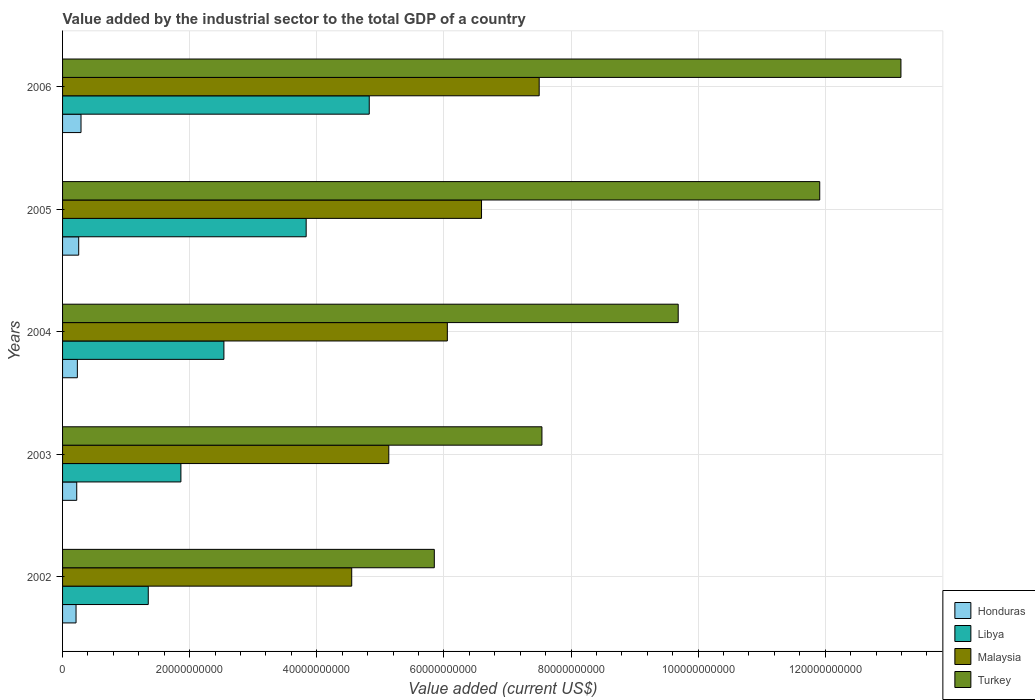Are the number of bars per tick equal to the number of legend labels?
Keep it short and to the point. Yes. Are the number of bars on each tick of the Y-axis equal?
Provide a short and direct response. Yes. What is the label of the 5th group of bars from the top?
Make the answer very short. 2002. In how many cases, is the number of bars for a given year not equal to the number of legend labels?
Your response must be concise. 0. What is the value added by the industrial sector to the total GDP in Malaysia in 2005?
Give a very brief answer. 6.59e+1. Across all years, what is the maximum value added by the industrial sector to the total GDP in Libya?
Your answer should be compact. 4.83e+1. Across all years, what is the minimum value added by the industrial sector to the total GDP in Turkey?
Give a very brief answer. 5.85e+1. In which year was the value added by the industrial sector to the total GDP in Malaysia maximum?
Provide a succinct answer. 2006. What is the total value added by the industrial sector to the total GDP in Malaysia in the graph?
Keep it short and to the point. 2.98e+11. What is the difference between the value added by the industrial sector to the total GDP in Malaysia in 2004 and that in 2005?
Ensure brevity in your answer.  -5.38e+09. What is the difference between the value added by the industrial sector to the total GDP in Malaysia in 2006 and the value added by the industrial sector to the total GDP in Honduras in 2003?
Provide a succinct answer. 7.28e+1. What is the average value added by the industrial sector to the total GDP in Malaysia per year?
Provide a succinct answer. 5.97e+1. In the year 2005, what is the difference between the value added by the industrial sector to the total GDP in Malaysia and value added by the industrial sector to the total GDP in Libya?
Your response must be concise. 2.76e+1. In how many years, is the value added by the industrial sector to the total GDP in Honduras greater than 44000000000 US$?
Ensure brevity in your answer.  0. What is the ratio of the value added by the industrial sector to the total GDP in Turkey in 2004 to that in 2005?
Provide a short and direct response. 0.81. Is the difference between the value added by the industrial sector to the total GDP in Malaysia in 2002 and 2005 greater than the difference between the value added by the industrial sector to the total GDP in Libya in 2002 and 2005?
Provide a short and direct response. Yes. What is the difference between the highest and the second highest value added by the industrial sector to the total GDP in Libya?
Provide a succinct answer. 9.93e+09. What is the difference between the highest and the lowest value added by the industrial sector to the total GDP in Turkey?
Ensure brevity in your answer.  7.34e+1. In how many years, is the value added by the industrial sector to the total GDP in Malaysia greater than the average value added by the industrial sector to the total GDP in Malaysia taken over all years?
Offer a very short reply. 3. Is the sum of the value added by the industrial sector to the total GDP in Malaysia in 2002 and 2003 greater than the maximum value added by the industrial sector to the total GDP in Libya across all years?
Offer a terse response. Yes. Is it the case that in every year, the sum of the value added by the industrial sector to the total GDP in Malaysia and value added by the industrial sector to the total GDP in Libya is greater than the sum of value added by the industrial sector to the total GDP in Honduras and value added by the industrial sector to the total GDP in Turkey?
Keep it short and to the point. Yes. What does the 3rd bar from the top in 2005 represents?
Offer a terse response. Libya. What does the 1st bar from the bottom in 2002 represents?
Ensure brevity in your answer.  Honduras. Is it the case that in every year, the sum of the value added by the industrial sector to the total GDP in Malaysia and value added by the industrial sector to the total GDP in Libya is greater than the value added by the industrial sector to the total GDP in Turkey?
Your response must be concise. No. How many years are there in the graph?
Your answer should be compact. 5. Does the graph contain grids?
Your answer should be very brief. Yes. What is the title of the graph?
Give a very brief answer. Value added by the industrial sector to the total GDP of a country. What is the label or title of the X-axis?
Keep it short and to the point. Value added (current US$). What is the Value added (current US$) of Honduras in 2002?
Your response must be concise. 2.12e+09. What is the Value added (current US$) of Libya in 2002?
Provide a succinct answer. 1.35e+1. What is the Value added (current US$) in Malaysia in 2002?
Keep it short and to the point. 4.55e+1. What is the Value added (current US$) of Turkey in 2002?
Provide a succinct answer. 5.85e+1. What is the Value added (current US$) in Honduras in 2003?
Offer a very short reply. 2.23e+09. What is the Value added (current US$) in Libya in 2003?
Provide a succinct answer. 1.86e+1. What is the Value added (current US$) of Malaysia in 2003?
Ensure brevity in your answer.  5.13e+1. What is the Value added (current US$) in Turkey in 2003?
Give a very brief answer. 7.54e+1. What is the Value added (current US$) in Honduras in 2004?
Your answer should be very brief. 2.33e+09. What is the Value added (current US$) in Libya in 2004?
Make the answer very short. 2.54e+1. What is the Value added (current US$) in Malaysia in 2004?
Your response must be concise. 6.05e+1. What is the Value added (current US$) of Turkey in 2004?
Ensure brevity in your answer.  9.69e+1. What is the Value added (current US$) of Honduras in 2005?
Your answer should be very brief. 2.54e+09. What is the Value added (current US$) of Libya in 2005?
Provide a short and direct response. 3.83e+1. What is the Value added (current US$) of Malaysia in 2005?
Your answer should be very brief. 6.59e+1. What is the Value added (current US$) of Turkey in 2005?
Offer a very short reply. 1.19e+11. What is the Value added (current US$) of Honduras in 2006?
Your response must be concise. 2.90e+09. What is the Value added (current US$) in Libya in 2006?
Provide a succinct answer. 4.83e+1. What is the Value added (current US$) in Malaysia in 2006?
Your answer should be very brief. 7.50e+1. What is the Value added (current US$) in Turkey in 2006?
Offer a very short reply. 1.32e+11. Across all years, what is the maximum Value added (current US$) in Honduras?
Give a very brief answer. 2.90e+09. Across all years, what is the maximum Value added (current US$) in Libya?
Make the answer very short. 4.83e+1. Across all years, what is the maximum Value added (current US$) in Malaysia?
Offer a terse response. 7.50e+1. Across all years, what is the maximum Value added (current US$) in Turkey?
Ensure brevity in your answer.  1.32e+11. Across all years, what is the minimum Value added (current US$) of Honduras?
Your answer should be compact. 2.12e+09. Across all years, what is the minimum Value added (current US$) of Libya?
Your answer should be very brief. 1.35e+1. Across all years, what is the minimum Value added (current US$) in Malaysia?
Your response must be concise. 4.55e+1. Across all years, what is the minimum Value added (current US$) in Turkey?
Offer a very short reply. 5.85e+1. What is the total Value added (current US$) of Honduras in the graph?
Offer a terse response. 1.21e+1. What is the total Value added (current US$) of Libya in the graph?
Make the answer very short. 1.44e+11. What is the total Value added (current US$) of Malaysia in the graph?
Keep it short and to the point. 2.98e+11. What is the total Value added (current US$) of Turkey in the graph?
Provide a short and direct response. 4.82e+11. What is the difference between the Value added (current US$) of Honduras in 2002 and that in 2003?
Make the answer very short. -1.08e+08. What is the difference between the Value added (current US$) in Libya in 2002 and that in 2003?
Offer a terse response. -5.14e+09. What is the difference between the Value added (current US$) of Malaysia in 2002 and that in 2003?
Keep it short and to the point. -5.83e+09. What is the difference between the Value added (current US$) in Turkey in 2002 and that in 2003?
Give a very brief answer. -1.69e+1. What is the difference between the Value added (current US$) in Honduras in 2002 and that in 2004?
Provide a short and direct response. -2.08e+08. What is the difference between the Value added (current US$) of Libya in 2002 and that in 2004?
Keep it short and to the point. -1.19e+1. What is the difference between the Value added (current US$) in Malaysia in 2002 and that in 2004?
Give a very brief answer. -1.50e+1. What is the difference between the Value added (current US$) of Turkey in 2002 and that in 2004?
Keep it short and to the point. -3.84e+1. What is the difference between the Value added (current US$) of Honduras in 2002 and that in 2005?
Offer a very short reply. -4.18e+08. What is the difference between the Value added (current US$) of Libya in 2002 and that in 2005?
Give a very brief answer. -2.48e+1. What is the difference between the Value added (current US$) of Malaysia in 2002 and that in 2005?
Provide a short and direct response. -2.04e+1. What is the difference between the Value added (current US$) in Turkey in 2002 and that in 2005?
Offer a very short reply. -6.06e+1. What is the difference between the Value added (current US$) of Honduras in 2002 and that in 2006?
Provide a short and direct response. -7.84e+08. What is the difference between the Value added (current US$) in Libya in 2002 and that in 2006?
Your response must be concise. -3.48e+1. What is the difference between the Value added (current US$) of Malaysia in 2002 and that in 2006?
Give a very brief answer. -2.95e+1. What is the difference between the Value added (current US$) of Turkey in 2002 and that in 2006?
Offer a very short reply. -7.34e+1. What is the difference between the Value added (current US$) in Honduras in 2003 and that in 2004?
Offer a terse response. -9.98e+07. What is the difference between the Value added (current US$) of Libya in 2003 and that in 2004?
Ensure brevity in your answer.  -6.77e+09. What is the difference between the Value added (current US$) of Malaysia in 2003 and that in 2004?
Provide a short and direct response. -9.21e+09. What is the difference between the Value added (current US$) of Turkey in 2003 and that in 2004?
Make the answer very short. -2.14e+1. What is the difference between the Value added (current US$) in Honduras in 2003 and that in 2005?
Your answer should be very brief. -3.10e+08. What is the difference between the Value added (current US$) of Libya in 2003 and that in 2005?
Your answer should be very brief. -1.97e+1. What is the difference between the Value added (current US$) of Malaysia in 2003 and that in 2005?
Your response must be concise. -1.46e+1. What is the difference between the Value added (current US$) in Turkey in 2003 and that in 2005?
Offer a very short reply. -4.37e+1. What is the difference between the Value added (current US$) of Honduras in 2003 and that in 2006?
Provide a short and direct response. -6.76e+08. What is the difference between the Value added (current US$) of Libya in 2003 and that in 2006?
Provide a short and direct response. -2.96e+1. What is the difference between the Value added (current US$) in Malaysia in 2003 and that in 2006?
Your response must be concise. -2.37e+1. What is the difference between the Value added (current US$) of Turkey in 2003 and that in 2006?
Your response must be concise. -5.65e+1. What is the difference between the Value added (current US$) in Honduras in 2004 and that in 2005?
Your answer should be very brief. -2.10e+08. What is the difference between the Value added (current US$) of Libya in 2004 and that in 2005?
Your answer should be very brief. -1.29e+1. What is the difference between the Value added (current US$) in Malaysia in 2004 and that in 2005?
Give a very brief answer. -5.38e+09. What is the difference between the Value added (current US$) in Turkey in 2004 and that in 2005?
Offer a very short reply. -2.23e+1. What is the difference between the Value added (current US$) in Honduras in 2004 and that in 2006?
Your answer should be compact. -5.76e+08. What is the difference between the Value added (current US$) of Libya in 2004 and that in 2006?
Offer a terse response. -2.29e+1. What is the difference between the Value added (current US$) of Malaysia in 2004 and that in 2006?
Offer a terse response. -1.45e+1. What is the difference between the Value added (current US$) of Turkey in 2004 and that in 2006?
Your answer should be compact. -3.50e+1. What is the difference between the Value added (current US$) of Honduras in 2005 and that in 2006?
Your answer should be very brief. -3.66e+08. What is the difference between the Value added (current US$) of Libya in 2005 and that in 2006?
Give a very brief answer. -9.93e+09. What is the difference between the Value added (current US$) in Malaysia in 2005 and that in 2006?
Give a very brief answer. -9.07e+09. What is the difference between the Value added (current US$) in Turkey in 2005 and that in 2006?
Give a very brief answer. -1.28e+1. What is the difference between the Value added (current US$) in Honduras in 2002 and the Value added (current US$) in Libya in 2003?
Ensure brevity in your answer.  -1.65e+1. What is the difference between the Value added (current US$) of Honduras in 2002 and the Value added (current US$) of Malaysia in 2003?
Your answer should be compact. -4.92e+1. What is the difference between the Value added (current US$) of Honduras in 2002 and the Value added (current US$) of Turkey in 2003?
Your answer should be very brief. -7.33e+1. What is the difference between the Value added (current US$) of Libya in 2002 and the Value added (current US$) of Malaysia in 2003?
Ensure brevity in your answer.  -3.78e+1. What is the difference between the Value added (current US$) of Libya in 2002 and the Value added (current US$) of Turkey in 2003?
Provide a short and direct response. -6.19e+1. What is the difference between the Value added (current US$) of Malaysia in 2002 and the Value added (current US$) of Turkey in 2003?
Your response must be concise. -2.99e+1. What is the difference between the Value added (current US$) in Honduras in 2002 and the Value added (current US$) in Libya in 2004?
Offer a terse response. -2.33e+1. What is the difference between the Value added (current US$) in Honduras in 2002 and the Value added (current US$) in Malaysia in 2004?
Provide a succinct answer. -5.84e+1. What is the difference between the Value added (current US$) of Honduras in 2002 and the Value added (current US$) of Turkey in 2004?
Ensure brevity in your answer.  -9.47e+1. What is the difference between the Value added (current US$) in Libya in 2002 and the Value added (current US$) in Malaysia in 2004?
Offer a very short reply. -4.71e+1. What is the difference between the Value added (current US$) of Libya in 2002 and the Value added (current US$) of Turkey in 2004?
Provide a succinct answer. -8.34e+1. What is the difference between the Value added (current US$) in Malaysia in 2002 and the Value added (current US$) in Turkey in 2004?
Offer a terse response. -5.14e+1. What is the difference between the Value added (current US$) of Honduras in 2002 and the Value added (current US$) of Libya in 2005?
Ensure brevity in your answer.  -3.62e+1. What is the difference between the Value added (current US$) in Honduras in 2002 and the Value added (current US$) in Malaysia in 2005?
Your response must be concise. -6.38e+1. What is the difference between the Value added (current US$) in Honduras in 2002 and the Value added (current US$) in Turkey in 2005?
Make the answer very short. -1.17e+11. What is the difference between the Value added (current US$) of Libya in 2002 and the Value added (current US$) of Malaysia in 2005?
Offer a terse response. -5.24e+1. What is the difference between the Value added (current US$) of Libya in 2002 and the Value added (current US$) of Turkey in 2005?
Offer a terse response. -1.06e+11. What is the difference between the Value added (current US$) of Malaysia in 2002 and the Value added (current US$) of Turkey in 2005?
Your answer should be very brief. -7.36e+1. What is the difference between the Value added (current US$) of Honduras in 2002 and the Value added (current US$) of Libya in 2006?
Offer a terse response. -4.61e+1. What is the difference between the Value added (current US$) in Honduras in 2002 and the Value added (current US$) in Malaysia in 2006?
Your answer should be very brief. -7.29e+1. What is the difference between the Value added (current US$) of Honduras in 2002 and the Value added (current US$) of Turkey in 2006?
Keep it short and to the point. -1.30e+11. What is the difference between the Value added (current US$) in Libya in 2002 and the Value added (current US$) in Malaysia in 2006?
Make the answer very short. -6.15e+1. What is the difference between the Value added (current US$) in Libya in 2002 and the Value added (current US$) in Turkey in 2006?
Make the answer very short. -1.18e+11. What is the difference between the Value added (current US$) in Malaysia in 2002 and the Value added (current US$) in Turkey in 2006?
Give a very brief answer. -8.64e+1. What is the difference between the Value added (current US$) of Honduras in 2003 and the Value added (current US$) of Libya in 2004?
Your response must be concise. -2.32e+1. What is the difference between the Value added (current US$) in Honduras in 2003 and the Value added (current US$) in Malaysia in 2004?
Keep it short and to the point. -5.83e+1. What is the difference between the Value added (current US$) in Honduras in 2003 and the Value added (current US$) in Turkey in 2004?
Offer a very short reply. -9.46e+1. What is the difference between the Value added (current US$) in Libya in 2003 and the Value added (current US$) in Malaysia in 2004?
Offer a very short reply. -4.19e+1. What is the difference between the Value added (current US$) in Libya in 2003 and the Value added (current US$) in Turkey in 2004?
Provide a succinct answer. -7.82e+1. What is the difference between the Value added (current US$) in Malaysia in 2003 and the Value added (current US$) in Turkey in 2004?
Keep it short and to the point. -4.55e+1. What is the difference between the Value added (current US$) of Honduras in 2003 and the Value added (current US$) of Libya in 2005?
Keep it short and to the point. -3.61e+1. What is the difference between the Value added (current US$) of Honduras in 2003 and the Value added (current US$) of Malaysia in 2005?
Provide a short and direct response. -6.37e+1. What is the difference between the Value added (current US$) in Honduras in 2003 and the Value added (current US$) in Turkey in 2005?
Give a very brief answer. -1.17e+11. What is the difference between the Value added (current US$) in Libya in 2003 and the Value added (current US$) in Malaysia in 2005?
Your answer should be compact. -4.73e+1. What is the difference between the Value added (current US$) in Libya in 2003 and the Value added (current US$) in Turkey in 2005?
Keep it short and to the point. -1.01e+11. What is the difference between the Value added (current US$) in Malaysia in 2003 and the Value added (current US$) in Turkey in 2005?
Your answer should be very brief. -6.78e+1. What is the difference between the Value added (current US$) of Honduras in 2003 and the Value added (current US$) of Libya in 2006?
Keep it short and to the point. -4.60e+1. What is the difference between the Value added (current US$) of Honduras in 2003 and the Value added (current US$) of Malaysia in 2006?
Your answer should be compact. -7.28e+1. What is the difference between the Value added (current US$) in Honduras in 2003 and the Value added (current US$) in Turkey in 2006?
Your answer should be very brief. -1.30e+11. What is the difference between the Value added (current US$) of Libya in 2003 and the Value added (current US$) of Malaysia in 2006?
Your answer should be compact. -5.64e+1. What is the difference between the Value added (current US$) in Libya in 2003 and the Value added (current US$) in Turkey in 2006?
Ensure brevity in your answer.  -1.13e+11. What is the difference between the Value added (current US$) of Malaysia in 2003 and the Value added (current US$) of Turkey in 2006?
Give a very brief answer. -8.06e+1. What is the difference between the Value added (current US$) of Honduras in 2004 and the Value added (current US$) of Libya in 2005?
Give a very brief answer. -3.60e+1. What is the difference between the Value added (current US$) of Honduras in 2004 and the Value added (current US$) of Malaysia in 2005?
Provide a short and direct response. -6.36e+1. What is the difference between the Value added (current US$) of Honduras in 2004 and the Value added (current US$) of Turkey in 2005?
Ensure brevity in your answer.  -1.17e+11. What is the difference between the Value added (current US$) of Libya in 2004 and the Value added (current US$) of Malaysia in 2005?
Keep it short and to the point. -4.05e+1. What is the difference between the Value added (current US$) of Libya in 2004 and the Value added (current US$) of Turkey in 2005?
Provide a succinct answer. -9.37e+1. What is the difference between the Value added (current US$) in Malaysia in 2004 and the Value added (current US$) in Turkey in 2005?
Your response must be concise. -5.86e+1. What is the difference between the Value added (current US$) in Honduras in 2004 and the Value added (current US$) in Libya in 2006?
Keep it short and to the point. -4.59e+1. What is the difference between the Value added (current US$) of Honduras in 2004 and the Value added (current US$) of Malaysia in 2006?
Provide a short and direct response. -7.27e+1. What is the difference between the Value added (current US$) of Honduras in 2004 and the Value added (current US$) of Turkey in 2006?
Your response must be concise. -1.30e+11. What is the difference between the Value added (current US$) in Libya in 2004 and the Value added (current US$) in Malaysia in 2006?
Your answer should be compact. -4.96e+1. What is the difference between the Value added (current US$) of Libya in 2004 and the Value added (current US$) of Turkey in 2006?
Your answer should be compact. -1.07e+11. What is the difference between the Value added (current US$) in Malaysia in 2004 and the Value added (current US$) in Turkey in 2006?
Your answer should be very brief. -7.14e+1. What is the difference between the Value added (current US$) of Honduras in 2005 and the Value added (current US$) of Libya in 2006?
Your answer should be compact. -4.57e+1. What is the difference between the Value added (current US$) in Honduras in 2005 and the Value added (current US$) in Malaysia in 2006?
Give a very brief answer. -7.25e+1. What is the difference between the Value added (current US$) in Honduras in 2005 and the Value added (current US$) in Turkey in 2006?
Offer a very short reply. -1.29e+11. What is the difference between the Value added (current US$) of Libya in 2005 and the Value added (current US$) of Malaysia in 2006?
Your answer should be compact. -3.67e+1. What is the difference between the Value added (current US$) in Libya in 2005 and the Value added (current US$) in Turkey in 2006?
Your response must be concise. -9.36e+1. What is the difference between the Value added (current US$) in Malaysia in 2005 and the Value added (current US$) in Turkey in 2006?
Your answer should be compact. -6.60e+1. What is the average Value added (current US$) in Honduras per year?
Offer a terse response. 2.42e+09. What is the average Value added (current US$) of Libya per year?
Make the answer very short. 2.88e+1. What is the average Value added (current US$) of Malaysia per year?
Offer a terse response. 5.97e+1. What is the average Value added (current US$) of Turkey per year?
Offer a terse response. 9.64e+1. In the year 2002, what is the difference between the Value added (current US$) of Honduras and Value added (current US$) of Libya?
Offer a terse response. -1.14e+1. In the year 2002, what is the difference between the Value added (current US$) in Honduras and Value added (current US$) in Malaysia?
Make the answer very short. -4.34e+1. In the year 2002, what is the difference between the Value added (current US$) in Honduras and Value added (current US$) in Turkey?
Provide a short and direct response. -5.64e+1. In the year 2002, what is the difference between the Value added (current US$) in Libya and Value added (current US$) in Malaysia?
Provide a short and direct response. -3.20e+1. In the year 2002, what is the difference between the Value added (current US$) in Libya and Value added (current US$) in Turkey?
Ensure brevity in your answer.  -4.50e+1. In the year 2002, what is the difference between the Value added (current US$) of Malaysia and Value added (current US$) of Turkey?
Give a very brief answer. -1.30e+1. In the year 2003, what is the difference between the Value added (current US$) of Honduras and Value added (current US$) of Libya?
Offer a terse response. -1.64e+1. In the year 2003, what is the difference between the Value added (current US$) of Honduras and Value added (current US$) of Malaysia?
Your answer should be very brief. -4.91e+1. In the year 2003, what is the difference between the Value added (current US$) in Honduras and Value added (current US$) in Turkey?
Provide a short and direct response. -7.32e+1. In the year 2003, what is the difference between the Value added (current US$) in Libya and Value added (current US$) in Malaysia?
Offer a terse response. -3.27e+1. In the year 2003, what is the difference between the Value added (current US$) of Libya and Value added (current US$) of Turkey?
Offer a very short reply. -5.68e+1. In the year 2003, what is the difference between the Value added (current US$) in Malaysia and Value added (current US$) in Turkey?
Keep it short and to the point. -2.41e+1. In the year 2004, what is the difference between the Value added (current US$) in Honduras and Value added (current US$) in Libya?
Make the answer very short. -2.31e+1. In the year 2004, what is the difference between the Value added (current US$) in Honduras and Value added (current US$) in Malaysia?
Provide a short and direct response. -5.82e+1. In the year 2004, what is the difference between the Value added (current US$) of Honduras and Value added (current US$) of Turkey?
Offer a terse response. -9.45e+1. In the year 2004, what is the difference between the Value added (current US$) of Libya and Value added (current US$) of Malaysia?
Make the answer very short. -3.52e+1. In the year 2004, what is the difference between the Value added (current US$) of Libya and Value added (current US$) of Turkey?
Provide a short and direct response. -7.15e+1. In the year 2004, what is the difference between the Value added (current US$) in Malaysia and Value added (current US$) in Turkey?
Give a very brief answer. -3.63e+1. In the year 2005, what is the difference between the Value added (current US$) of Honduras and Value added (current US$) of Libya?
Offer a very short reply. -3.58e+1. In the year 2005, what is the difference between the Value added (current US$) in Honduras and Value added (current US$) in Malaysia?
Make the answer very short. -6.34e+1. In the year 2005, what is the difference between the Value added (current US$) of Honduras and Value added (current US$) of Turkey?
Your answer should be compact. -1.17e+11. In the year 2005, what is the difference between the Value added (current US$) in Libya and Value added (current US$) in Malaysia?
Provide a short and direct response. -2.76e+1. In the year 2005, what is the difference between the Value added (current US$) of Libya and Value added (current US$) of Turkey?
Your response must be concise. -8.08e+1. In the year 2005, what is the difference between the Value added (current US$) in Malaysia and Value added (current US$) in Turkey?
Keep it short and to the point. -5.32e+1. In the year 2006, what is the difference between the Value added (current US$) of Honduras and Value added (current US$) of Libya?
Ensure brevity in your answer.  -4.54e+1. In the year 2006, what is the difference between the Value added (current US$) in Honduras and Value added (current US$) in Malaysia?
Give a very brief answer. -7.21e+1. In the year 2006, what is the difference between the Value added (current US$) of Honduras and Value added (current US$) of Turkey?
Your answer should be compact. -1.29e+11. In the year 2006, what is the difference between the Value added (current US$) of Libya and Value added (current US$) of Malaysia?
Provide a succinct answer. -2.67e+1. In the year 2006, what is the difference between the Value added (current US$) of Libya and Value added (current US$) of Turkey?
Offer a terse response. -8.37e+1. In the year 2006, what is the difference between the Value added (current US$) of Malaysia and Value added (current US$) of Turkey?
Your answer should be very brief. -5.69e+1. What is the ratio of the Value added (current US$) of Honduras in 2002 to that in 2003?
Offer a very short reply. 0.95. What is the ratio of the Value added (current US$) in Libya in 2002 to that in 2003?
Ensure brevity in your answer.  0.72. What is the ratio of the Value added (current US$) in Malaysia in 2002 to that in 2003?
Your response must be concise. 0.89. What is the ratio of the Value added (current US$) of Turkey in 2002 to that in 2003?
Keep it short and to the point. 0.78. What is the ratio of the Value added (current US$) of Honduras in 2002 to that in 2004?
Your response must be concise. 0.91. What is the ratio of the Value added (current US$) of Libya in 2002 to that in 2004?
Ensure brevity in your answer.  0.53. What is the ratio of the Value added (current US$) of Malaysia in 2002 to that in 2004?
Offer a terse response. 0.75. What is the ratio of the Value added (current US$) in Turkey in 2002 to that in 2004?
Keep it short and to the point. 0.6. What is the ratio of the Value added (current US$) in Honduras in 2002 to that in 2005?
Ensure brevity in your answer.  0.84. What is the ratio of the Value added (current US$) in Libya in 2002 to that in 2005?
Your response must be concise. 0.35. What is the ratio of the Value added (current US$) of Malaysia in 2002 to that in 2005?
Make the answer very short. 0.69. What is the ratio of the Value added (current US$) of Turkey in 2002 to that in 2005?
Your answer should be very brief. 0.49. What is the ratio of the Value added (current US$) of Honduras in 2002 to that in 2006?
Make the answer very short. 0.73. What is the ratio of the Value added (current US$) of Libya in 2002 to that in 2006?
Give a very brief answer. 0.28. What is the ratio of the Value added (current US$) of Malaysia in 2002 to that in 2006?
Provide a short and direct response. 0.61. What is the ratio of the Value added (current US$) in Turkey in 2002 to that in 2006?
Offer a terse response. 0.44. What is the ratio of the Value added (current US$) of Honduras in 2003 to that in 2004?
Ensure brevity in your answer.  0.96. What is the ratio of the Value added (current US$) of Libya in 2003 to that in 2004?
Your answer should be very brief. 0.73. What is the ratio of the Value added (current US$) in Malaysia in 2003 to that in 2004?
Offer a very short reply. 0.85. What is the ratio of the Value added (current US$) in Turkey in 2003 to that in 2004?
Your answer should be very brief. 0.78. What is the ratio of the Value added (current US$) in Honduras in 2003 to that in 2005?
Your response must be concise. 0.88. What is the ratio of the Value added (current US$) of Libya in 2003 to that in 2005?
Offer a very short reply. 0.49. What is the ratio of the Value added (current US$) in Malaysia in 2003 to that in 2005?
Give a very brief answer. 0.78. What is the ratio of the Value added (current US$) in Turkey in 2003 to that in 2005?
Your response must be concise. 0.63. What is the ratio of the Value added (current US$) of Honduras in 2003 to that in 2006?
Your answer should be very brief. 0.77. What is the ratio of the Value added (current US$) in Libya in 2003 to that in 2006?
Ensure brevity in your answer.  0.39. What is the ratio of the Value added (current US$) in Malaysia in 2003 to that in 2006?
Keep it short and to the point. 0.68. What is the ratio of the Value added (current US$) of Turkey in 2003 to that in 2006?
Keep it short and to the point. 0.57. What is the ratio of the Value added (current US$) in Honduras in 2004 to that in 2005?
Offer a very short reply. 0.92. What is the ratio of the Value added (current US$) in Libya in 2004 to that in 2005?
Your response must be concise. 0.66. What is the ratio of the Value added (current US$) in Malaysia in 2004 to that in 2005?
Your answer should be compact. 0.92. What is the ratio of the Value added (current US$) in Turkey in 2004 to that in 2005?
Provide a succinct answer. 0.81. What is the ratio of the Value added (current US$) of Honduras in 2004 to that in 2006?
Keep it short and to the point. 0.8. What is the ratio of the Value added (current US$) of Libya in 2004 to that in 2006?
Provide a short and direct response. 0.53. What is the ratio of the Value added (current US$) in Malaysia in 2004 to that in 2006?
Offer a terse response. 0.81. What is the ratio of the Value added (current US$) of Turkey in 2004 to that in 2006?
Your answer should be compact. 0.73. What is the ratio of the Value added (current US$) in Honduras in 2005 to that in 2006?
Offer a terse response. 0.87. What is the ratio of the Value added (current US$) of Libya in 2005 to that in 2006?
Provide a short and direct response. 0.79. What is the ratio of the Value added (current US$) in Malaysia in 2005 to that in 2006?
Offer a terse response. 0.88. What is the ratio of the Value added (current US$) of Turkey in 2005 to that in 2006?
Your answer should be compact. 0.9. What is the difference between the highest and the second highest Value added (current US$) in Honduras?
Ensure brevity in your answer.  3.66e+08. What is the difference between the highest and the second highest Value added (current US$) of Libya?
Offer a very short reply. 9.93e+09. What is the difference between the highest and the second highest Value added (current US$) of Malaysia?
Give a very brief answer. 9.07e+09. What is the difference between the highest and the second highest Value added (current US$) of Turkey?
Offer a terse response. 1.28e+1. What is the difference between the highest and the lowest Value added (current US$) in Honduras?
Offer a terse response. 7.84e+08. What is the difference between the highest and the lowest Value added (current US$) in Libya?
Ensure brevity in your answer.  3.48e+1. What is the difference between the highest and the lowest Value added (current US$) in Malaysia?
Provide a succinct answer. 2.95e+1. What is the difference between the highest and the lowest Value added (current US$) of Turkey?
Offer a very short reply. 7.34e+1. 